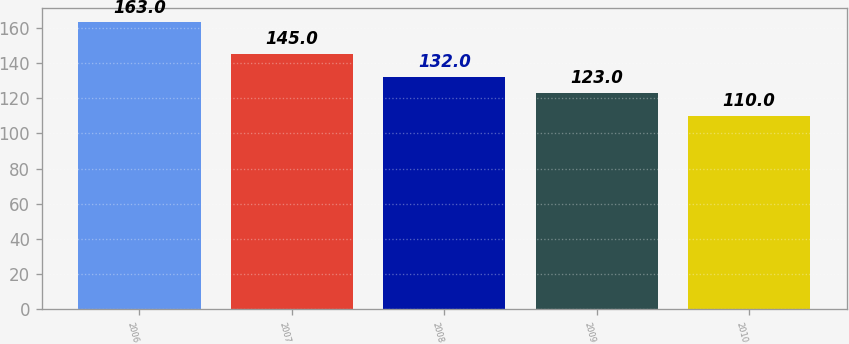<chart> <loc_0><loc_0><loc_500><loc_500><bar_chart><fcel>2006<fcel>2007<fcel>2008<fcel>2009<fcel>2010<nl><fcel>163<fcel>145<fcel>132<fcel>123<fcel>110<nl></chart> 